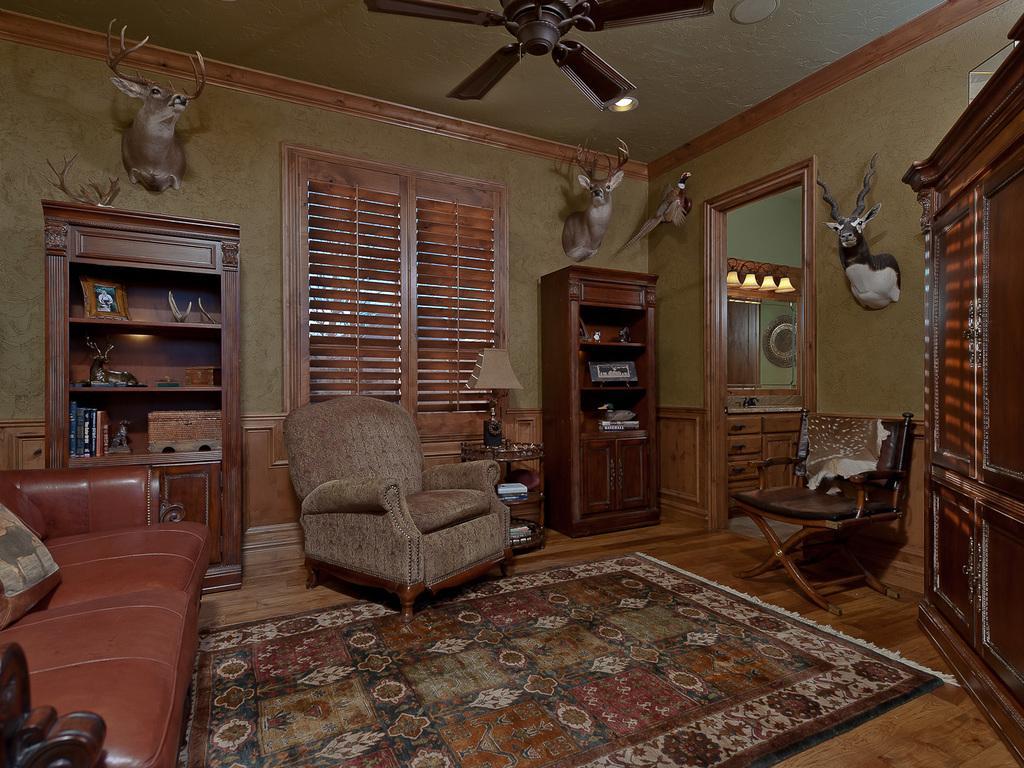Could you give a brief overview of what you see in this image? This looks like a living room. This is a couch and chairs. This is a carpet on the floor. I can see a lamp placed on the table. This is a ceiling fan attached to the rooftop. These are the animal faces attached to the wall. This looks like a rack with books,frame and few other things inside it. These are the lamps. I think this is the window which is closed. This looks like a wardrobe. 